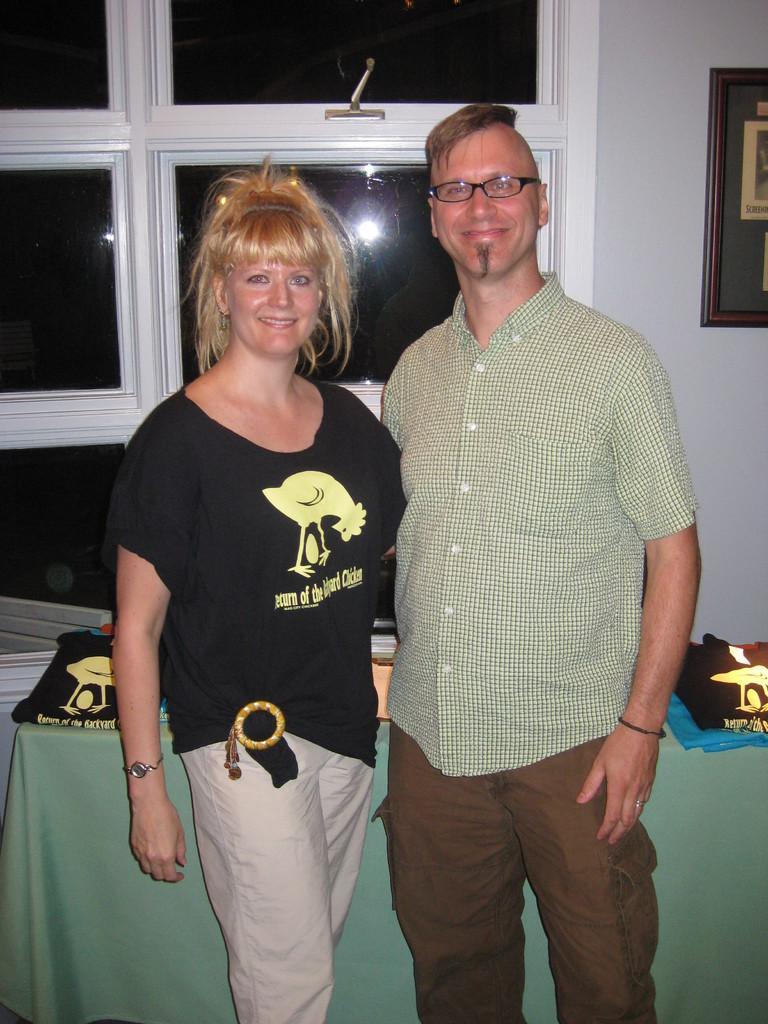Could you give a brief overview of what you see in this image? In the center of the image a lady and a man are standing. In the middle of the image there is a table. On the table we can see some clothes are there. At the top of the image we can see windows, wall, photo frame are present. 